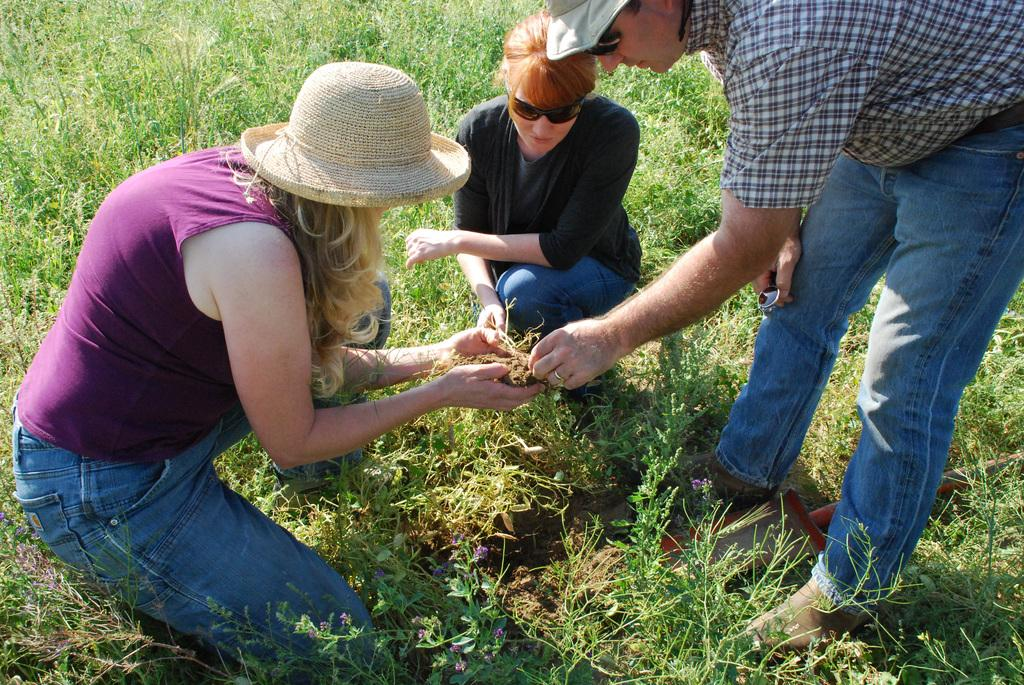Who or what can be seen in the image? There are people in the image. What is the surface beneath the people? The ground is visible in the image. What type of vegetation is present on the ground? Grass is present on the ground. Are there any other living organisms in the image besides people? Yes, there are plants in the image. What type of shop can be seen in the image? There is no shop present in the image. What kind of medical assistance is being provided in the image? There is no doctor or medical assistance present in the image. 